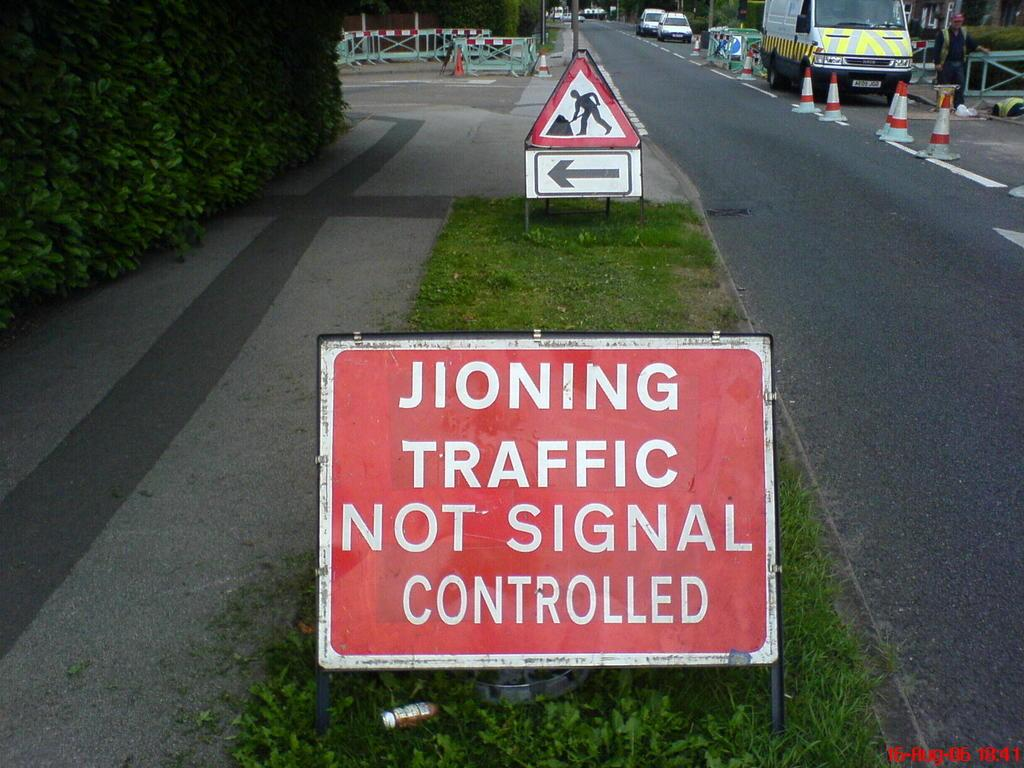<image>
Present a compact description of the photo's key features. A red and white sign with the words jioning traffic not signal controlled on it. 